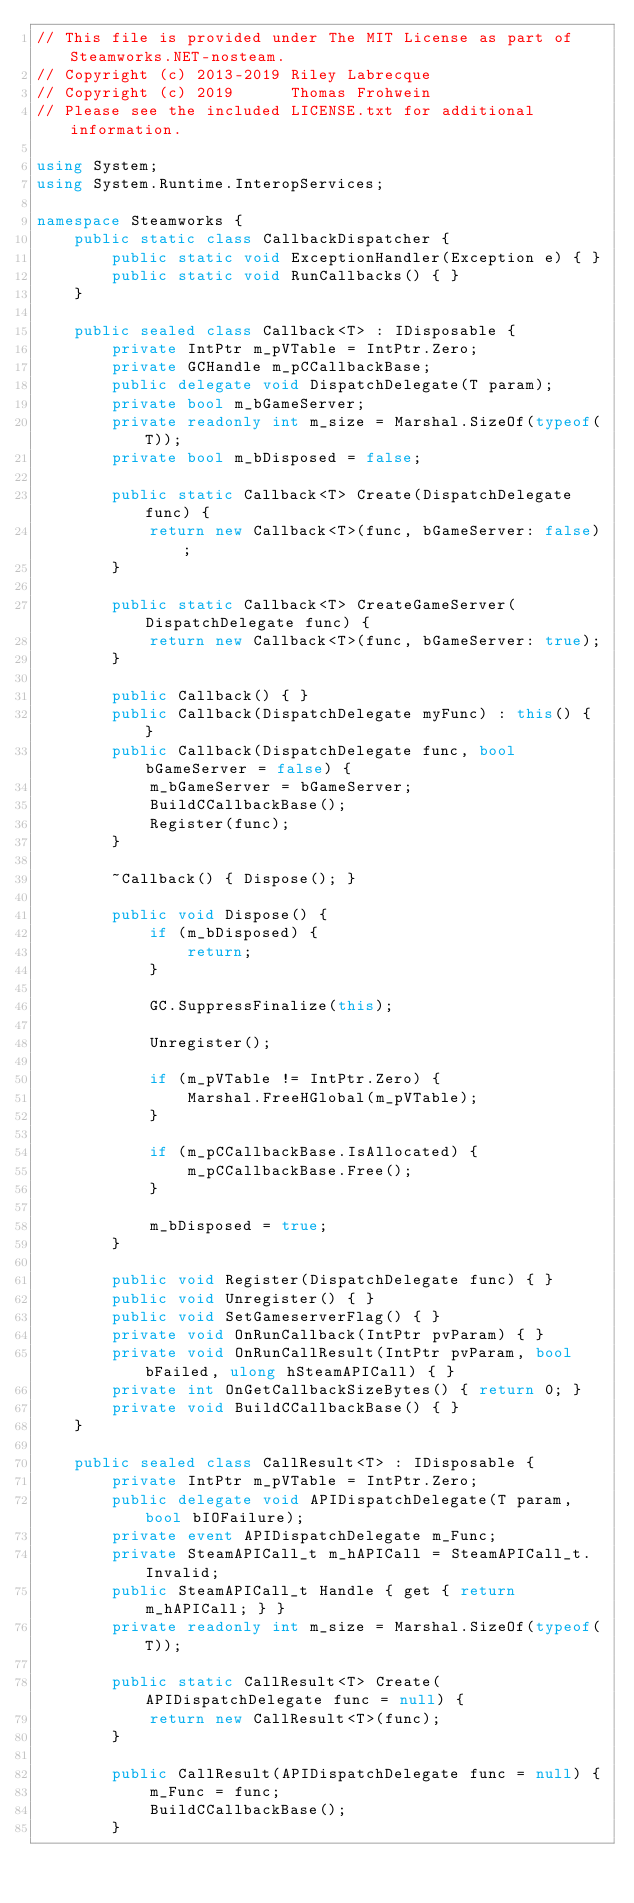Convert code to text. <code><loc_0><loc_0><loc_500><loc_500><_C#_>// This file is provided under The MIT License as part of Steamworks.NET-nosteam.
// Copyright (c) 2013-2019 Riley Labrecque
// Copyright (c) 2019      Thomas Frohwein
// Please see the included LICENSE.txt for additional information.

using System;
using System.Runtime.InteropServices;

namespace Steamworks {
	public static class CallbackDispatcher {
		public static void ExceptionHandler(Exception e) { }
		public static void RunCallbacks() { }
	}

	public sealed class Callback<T> : IDisposable {
		private IntPtr m_pVTable = IntPtr.Zero;
		private GCHandle m_pCCallbackBase;
		public delegate void DispatchDelegate(T param);
		private bool m_bGameServer;
		private readonly int m_size = Marshal.SizeOf(typeof(T));
		private bool m_bDisposed = false;

		public static Callback<T> Create(DispatchDelegate func) {
			return new Callback<T>(func, bGameServer: false);
		}

		public static Callback<T> CreateGameServer(DispatchDelegate func) {
			return new Callback<T>(func, bGameServer: true);
		}

		public Callback() { }
		public Callback(DispatchDelegate myFunc) : this() { }
		public Callback(DispatchDelegate func, bool bGameServer = false) {
			m_bGameServer = bGameServer;
			BuildCCallbackBase();
			Register(func);
		}

		~Callback() { Dispose(); }

		public void Dispose() {
			if (m_bDisposed) {
				return;
			}

			GC.SuppressFinalize(this);

			Unregister();

			if (m_pVTable != IntPtr.Zero) {
				Marshal.FreeHGlobal(m_pVTable);
			}

			if (m_pCCallbackBase.IsAllocated) {
				m_pCCallbackBase.Free();
			}

			m_bDisposed = true;
		}

		public void Register(DispatchDelegate func) { }
		public void Unregister() { }
		public void SetGameserverFlag() { }
		private void OnRunCallback(IntPtr pvParam) { }
		private void OnRunCallResult(IntPtr pvParam, bool bFailed, ulong hSteamAPICall) { }
		private int OnGetCallbackSizeBytes() { return 0; }
		private void BuildCCallbackBase() { }
	}

	public sealed class CallResult<T> : IDisposable {
		private IntPtr m_pVTable = IntPtr.Zero;
		public delegate void APIDispatchDelegate(T param, bool bIOFailure);
		private event APIDispatchDelegate m_Func;
		private SteamAPICall_t m_hAPICall = SteamAPICall_t.Invalid;
		public SteamAPICall_t Handle { get { return m_hAPICall; } }
		private readonly int m_size = Marshal.SizeOf(typeof(T));

		public static CallResult<T> Create(APIDispatchDelegate func = null) {
			return new CallResult<T>(func);
		}

		public CallResult(APIDispatchDelegate func = null) {
			m_Func = func;
			BuildCCallbackBase();
		}
</code> 